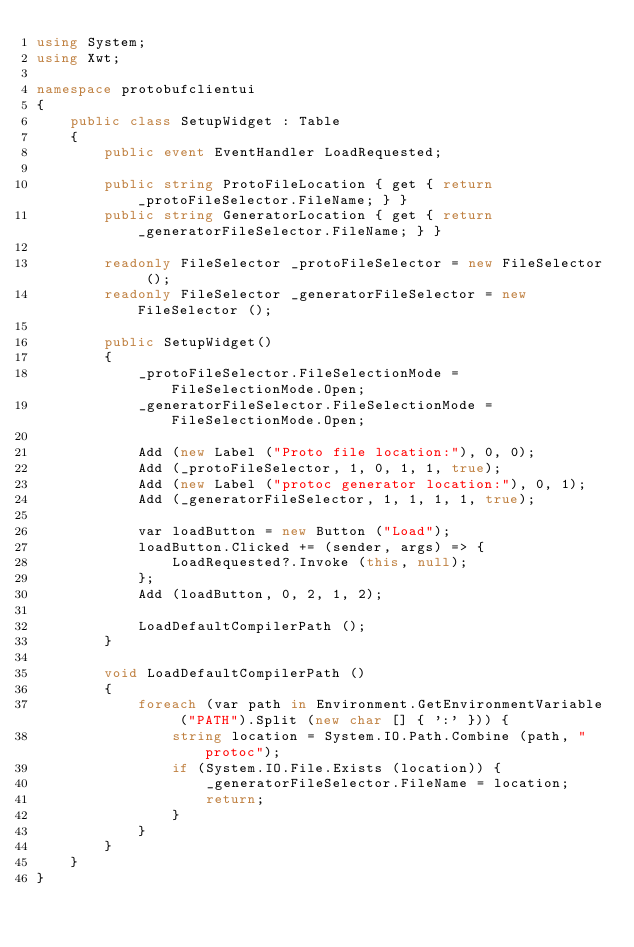<code> <loc_0><loc_0><loc_500><loc_500><_C#_>using System;
using Xwt;

namespace protobufclientui
{
    public class SetupWidget : Table
    {
        public event EventHandler LoadRequested;

        public string ProtoFileLocation { get { return _protoFileSelector.FileName; } }
        public string GeneratorLocation { get { return _generatorFileSelector.FileName; } }

        readonly FileSelector _protoFileSelector = new FileSelector ();
        readonly FileSelector _generatorFileSelector = new FileSelector ();

        public SetupWidget()
        {
            _protoFileSelector.FileSelectionMode = FileSelectionMode.Open;
            _generatorFileSelector.FileSelectionMode = FileSelectionMode.Open;

            Add (new Label ("Proto file location:"), 0, 0);
            Add (_protoFileSelector, 1, 0, 1, 1, true);
            Add (new Label ("protoc generator location:"), 0, 1);
            Add (_generatorFileSelector, 1, 1, 1, 1, true);
            
            var loadButton = new Button ("Load");
            loadButton.Clicked += (sender, args) => {
                LoadRequested?.Invoke (this, null);
            };
            Add (loadButton, 0, 2, 1, 2);

            LoadDefaultCompilerPath ();
        }

        void LoadDefaultCompilerPath ()
        {
            foreach (var path in Environment.GetEnvironmentVariable ("PATH").Split (new char [] { ':' })) {
                string location = System.IO.Path.Combine (path, "protoc");
                if (System.IO.File.Exists (location)) {
                    _generatorFileSelector.FileName = location;
                    return;
                }
            }
        }
    }
}


</code> 